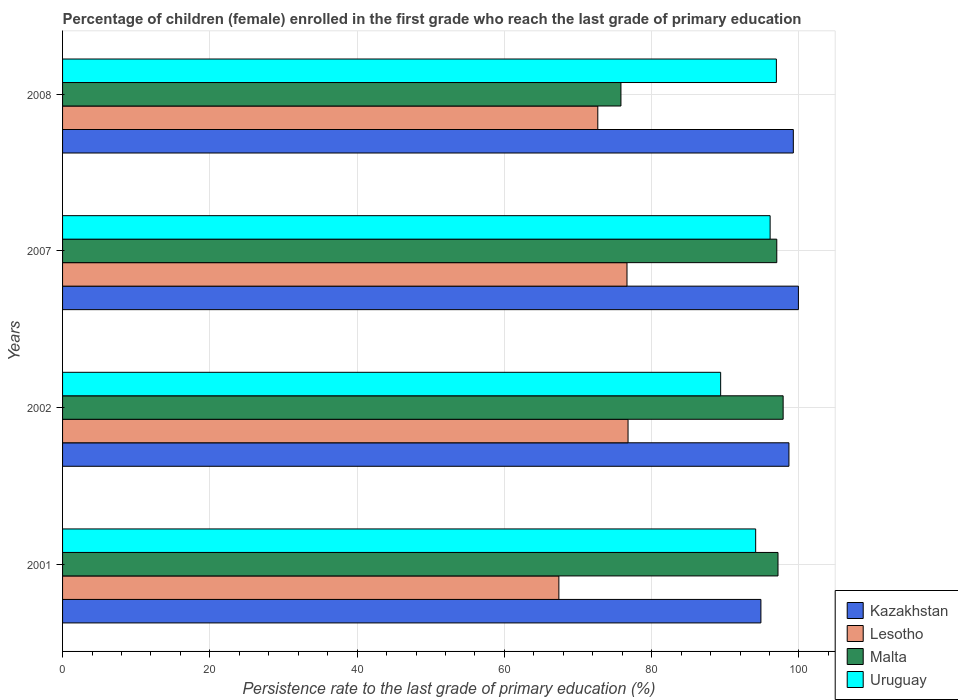How many groups of bars are there?
Provide a short and direct response. 4. Are the number of bars per tick equal to the number of legend labels?
Your answer should be compact. Yes. Are the number of bars on each tick of the Y-axis equal?
Your answer should be very brief. Yes. How many bars are there on the 4th tick from the top?
Ensure brevity in your answer.  4. What is the persistence rate of children in Kazakhstan in 2002?
Your answer should be compact. 98.65. Across all years, what is the maximum persistence rate of children in Malta?
Offer a very short reply. 97.86. Across all years, what is the minimum persistence rate of children in Uruguay?
Your response must be concise. 89.37. In which year was the persistence rate of children in Malta maximum?
Ensure brevity in your answer.  2002. In which year was the persistence rate of children in Kazakhstan minimum?
Keep it short and to the point. 2001. What is the total persistence rate of children in Lesotho in the graph?
Make the answer very short. 293.54. What is the difference between the persistence rate of children in Malta in 2001 and that in 2007?
Provide a short and direct response. 0.16. What is the difference between the persistence rate of children in Uruguay in 2007 and the persistence rate of children in Kazakhstan in 2001?
Make the answer very short. 1.25. What is the average persistence rate of children in Uruguay per year?
Your response must be concise. 94.13. In the year 2001, what is the difference between the persistence rate of children in Kazakhstan and persistence rate of children in Uruguay?
Your response must be concise. 0.71. What is the ratio of the persistence rate of children in Uruguay in 2002 to that in 2008?
Provide a short and direct response. 0.92. Is the difference between the persistence rate of children in Kazakhstan in 2001 and 2008 greater than the difference between the persistence rate of children in Uruguay in 2001 and 2008?
Ensure brevity in your answer.  No. What is the difference between the highest and the second highest persistence rate of children in Kazakhstan?
Keep it short and to the point. 0.69. What is the difference between the highest and the lowest persistence rate of children in Malta?
Make the answer very short. 22.03. In how many years, is the persistence rate of children in Kazakhstan greater than the average persistence rate of children in Kazakhstan taken over all years?
Your response must be concise. 3. Is the sum of the persistence rate of children in Malta in 2001 and 2008 greater than the maximum persistence rate of children in Kazakhstan across all years?
Offer a terse response. Yes. What does the 3rd bar from the top in 2007 represents?
Your answer should be very brief. Lesotho. What does the 4th bar from the bottom in 2002 represents?
Ensure brevity in your answer.  Uruguay. Is it the case that in every year, the sum of the persistence rate of children in Malta and persistence rate of children in Lesotho is greater than the persistence rate of children in Kazakhstan?
Offer a very short reply. Yes. Are all the bars in the graph horizontal?
Your answer should be compact. Yes. What is the difference between two consecutive major ticks on the X-axis?
Keep it short and to the point. 20. Are the values on the major ticks of X-axis written in scientific E-notation?
Give a very brief answer. No. Does the graph contain any zero values?
Ensure brevity in your answer.  No. How are the legend labels stacked?
Your answer should be compact. Vertical. What is the title of the graph?
Provide a short and direct response. Percentage of children (female) enrolled in the first grade who reach the last grade of primary education. Does "Tanzania" appear as one of the legend labels in the graph?
Provide a short and direct response. No. What is the label or title of the X-axis?
Your answer should be very brief. Persistence rate to the last grade of primary education (%). What is the label or title of the Y-axis?
Keep it short and to the point. Years. What is the Persistence rate to the last grade of primary education (%) of Kazakhstan in 2001?
Offer a terse response. 94.84. What is the Persistence rate to the last grade of primary education (%) of Lesotho in 2001?
Your answer should be very brief. 67.4. What is the Persistence rate to the last grade of primary education (%) of Malta in 2001?
Give a very brief answer. 97.16. What is the Persistence rate to the last grade of primary education (%) in Uruguay in 2001?
Make the answer very short. 94.13. What is the Persistence rate to the last grade of primary education (%) in Kazakhstan in 2002?
Provide a succinct answer. 98.65. What is the Persistence rate to the last grade of primary education (%) of Lesotho in 2002?
Your response must be concise. 76.79. What is the Persistence rate to the last grade of primary education (%) in Malta in 2002?
Your answer should be compact. 97.86. What is the Persistence rate to the last grade of primary education (%) of Uruguay in 2002?
Ensure brevity in your answer.  89.37. What is the Persistence rate to the last grade of primary education (%) of Kazakhstan in 2007?
Offer a very short reply. 99.93. What is the Persistence rate to the last grade of primary education (%) of Lesotho in 2007?
Make the answer very short. 76.65. What is the Persistence rate to the last grade of primary education (%) of Malta in 2007?
Make the answer very short. 97. What is the Persistence rate to the last grade of primary education (%) of Uruguay in 2007?
Keep it short and to the point. 96.09. What is the Persistence rate to the last grade of primary education (%) of Kazakhstan in 2008?
Offer a terse response. 99.24. What is the Persistence rate to the last grade of primary education (%) of Lesotho in 2008?
Offer a very short reply. 72.69. What is the Persistence rate to the last grade of primary education (%) of Malta in 2008?
Your answer should be compact. 75.83. What is the Persistence rate to the last grade of primary education (%) of Uruguay in 2008?
Give a very brief answer. 96.94. Across all years, what is the maximum Persistence rate to the last grade of primary education (%) in Kazakhstan?
Make the answer very short. 99.93. Across all years, what is the maximum Persistence rate to the last grade of primary education (%) of Lesotho?
Offer a terse response. 76.79. Across all years, what is the maximum Persistence rate to the last grade of primary education (%) of Malta?
Offer a terse response. 97.86. Across all years, what is the maximum Persistence rate to the last grade of primary education (%) of Uruguay?
Offer a very short reply. 96.94. Across all years, what is the minimum Persistence rate to the last grade of primary education (%) of Kazakhstan?
Give a very brief answer. 94.84. Across all years, what is the minimum Persistence rate to the last grade of primary education (%) of Lesotho?
Ensure brevity in your answer.  67.4. Across all years, what is the minimum Persistence rate to the last grade of primary education (%) in Malta?
Offer a terse response. 75.83. Across all years, what is the minimum Persistence rate to the last grade of primary education (%) of Uruguay?
Offer a very short reply. 89.37. What is the total Persistence rate to the last grade of primary education (%) in Kazakhstan in the graph?
Offer a very short reply. 392.66. What is the total Persistence rate to the last grade of primary education (%) of Lesotho in the graph?
Provide a succinct answer. 293.54. What is the total Persistence rate to the last grade of primary education (%) of Malta in the graph?
Provide a succinct answer. 367.85. What is the total Persistence rate to the last grade of primary education (%) in Uruguay in the graph?
Ensure brevity in your answer.  376.53. What is the difference between the Persistence rate to the last grade of primary education (%) of Kazakhstan in 2001 and that in 2002?
Your response must be concise. -3.81. What is the difference between the Persistence rate to the last grade of primary education (%) of Lesotho in 2001 and that in 2002?
Give a very brief answer. -9.39. What is the difference between the Persistence rate to the last grade of primary education (%) of Malta in 2001 and that in 2002?
Keep it short and to the point. -0.7. What is the difference between the Persistence rate to the last grade of primary education (%) of Uruguay in 2001 and that in 2002?
Your answer should be compact. 4.76. What is the difference between the Persistence rate to the last grade of primary education (%) in Kazakhstan in 2001 and that in 2007?
Your response must be concise. -5.09. What is the difference between the Persistence rate to the last grade of primary education (%) of Lesotho in 2001 and that in 2007?
Your answer should be compact. -9.25. What is the difference between the Persistence rate to the last grade of primary education (%) of Malta in 2001 and that in 2007?
Ensure brevity in your answer.  0.16. What is the difference between the Persistence rate to the last grade of primary education (%) of Uruguay in 2001 and that in 2007?
Offer a very short reply. -1.96. What is the difference between the Persistence rate to the last grade of primary education (%) of Kazakhstan in 2001 and that in 2008?
Your answer should be very brief. -4.4. What is the difference between the Persistence rate to the last grade of primary education (%) in Lesotho in 2001 and that in 2008?
Provide a succinct answer. -5.29. What is the difference between the Persistence rate to the last grade of primary education (%) of Malta in 2001 and that in 2008?
Give a very brief answer. 21.33. What is the difference between the Persistence rate to the last grade of primary education (%) in Uruguay in 2001 and that in 2008?
Ensure brevity in your answer.  -2.81. What is the difference between the Persistence rate to the last grade of primary education (%) of Kazakhstan in 2002 and that in 2007?
Your answer should be very brief. -1.29. What is the difference between the Persistence rate to the last grade of primary education (%) of Lesotho in 2002 and that in 2007?
Give a very brief answer. 0.14. What is the difference between the Persistence rate to the last grade of primary education (%) in Malta in 2002 and that in 2007?
Your response must be concise. 0.86. What is the difference between the Persistence rate to the last grade of primary education (%) in Uruguay in 2002 and that in 2007?
Give a very brief answer. -6.72. What is the difference between the Persistence rate to the last grade of primary education (%) in Kazakhstan in 2002 and that in 2008?
Offer a very short reply. -0.6. What is the difference between the Persistence rate to the last grade of primary education (%) in Lesotho in 2002 and that in 2008?
Provide a succinct answer. 4.11. What is the difference between the Persistence rate to the last grade of primary education (%) of Malta in 2002 and that in 2008?
Your answer should be compact. 22.03. What is the difference between the Persistence rate to the last grade of primary education (%) in Uruguay in 2002 and that in 2008?
Give a very brief answer. -7.57. What is the difference between the Persistence rate to the last grade of primary education (%) of Kazakhstan in 2007 and that in 2008?
Your answer should be very brief. 0.69. What is the difference between the Persistence rate to the last grade of primary education (%) of Lesotho in 2007 and that in 2008?
Make the answer very short. 3.97. What is the difference between the Persistence rate to the last grade of primary education (%) of Malta in 2007 and that in 2008?
Ensure brevity in your answer.  21.16. What is the difference between the Persistence rate to the last grade of primary education (%) in Uruguay in 2007 and that in 2008?
Provide a short and direct response. -0.85. What is the difference between the Persistence rate to the last grade of primary education (%) of Kazakhstan in 2001 and the Persistence rate to the last grade of primary education (%) of Lesotho in 2002?
Provide a short and direct response. 18.04. What is the difference between the Persistence rate to the last grade of primary education (%) of Kazakhstan in 2001 and the Persistence rate to the last grade of primary education (%) of Malta in 2002?
Ensure brevity in your answer.  -3.02. What is the difference between the Persistence rate to the last grade of primary education (%) in Kazakhstan in 2001 and the Persistence rate to the last grade of primary education (%) in Uruguay in 2002?
Keep it short and to the point. 5.47. What is the difference between the Persistence rate to the last grade of primary education (%) in Lesotho in 2001 and the Persistence rate to the last grade of primary education (%) in Malta in 2002?
Your answer should be compact. -30.46. What is the difference between the Persistence rate to the last grade of primary education (%) of Lesotho in 2001 and the Persistence rate to the last grade of primary education (%) of Uruguay in 2002?
Your answer should be very brief. -21.97. What is the difference between the Persistence rate to the last grade of primary education (%) in Malta in 2001 and the Persistence rate to the last grade of primary education (%) in Uruguay in 2002?
Keep it short and to the point. 7.79. What is the difference between the Persistence rate to the last grade of primary education (%) of Kazakhstan in 2001 and the Persistence rate to the last grade of primary education (%) of Lesotho in 2007?
Your answer should be very brief. 18.19. What is the difference between the Persistence rate to the last grade of primary education (%) in Kazakhstan in 2001 and the Persistence rate to the last grade of primary education (%) in Malta in 2007?
Your answer should be compact. -2.16. What is the difference between the Persistence rate to the last grade of primary education (%) in Kazakhstan in 2001 and the Persistence rate to the last grade of primary education (%) in Uruguay in 2007?
Your answer should be compact. -1.25. What is the difference between the Persistence rate to the last grade of primary education (%) of Lesotho in 2001 and the Persistence rate to the last grade of primary education (%) of Malta in 2007?
Your answer should be very brief. -29.59. What is the difference between the Persistence rate to the last grade of primary education (%) of Lesotho in 2001 and the Persistence rate to the last grade of primary education (%) of Uruguay in 2007?
Provide a short and direct response. -28.69. What is the difference between the Persistence rate to the last grade of primary education (%) in Malta in 2001 and the Persistence rate to the last grade of primary education (%) in Uruguay in 2007?
Your answer should be very brief. 1.07. What is the difference between the Persistence rate to the last grade of primary education (%) of Kazakhstan in 2001 and the Persistence rate to the last grade of primary education (%) of Lesotho in 2008?
Make the answer very short. 22.15. What is the difference between the Persistence rate to the last grade of primary education (%) of Kazakhstan in 2001 and the Persistence rate to the last grade of primary education (%) of Malta in 2008?
Give a very brief answer. 19.01. What is the difference between the Persistence rate to the last grade of primary education (%) of Kazakhstan in 2001 and the Persistence rate to the last grade of primary education (%) of Uruguay in 2008?
Provide a succinct answer. -2.1. What is the difference between the Persistence rate to the last grade of primary education (%) of Lesotho in 2001 and the Persistence rate to the last grade of primary education (%) of Malta in 2008?
Offer a very short reply. -8.43. What is the difference between the Persistence rate to the last grade of primary education (%) in Lesotho in 2001 and the Persistence rate to the last grade of primary education (%) in Uruguay in 2008?
Make the answer very short. -29.54. What is the difference between the Persistence rate to the last grade of primary education (%) in Malta in 2001 and the Persistence rate to the last grade of primary education (%) in Uruguay in 2008?
Your response must be concise. 0.22. What is the difference between the Persistence rate to the last grade of primary education (%) of Kazakhstan in 2002 and the Persistence rate to the last grade of primary education (%) of Lesotho in 2007?
Ensure brevity in your answer.  21.99. What is the difference between the Persistence rate to the last grade of primary education (%) of Kazakhstan in 2002 and the Persistence rate to the last grade of primary education (%) of Malta in 2007?
Ensure brevity in your answer.  1.65. What is the difference between the Persistence rate to the last grade of primary education (%) of Kazakhstan in 2002 and the Persistence rate to the last grade of primary education (%) of Uruguay in 2007?
Give a very brief answer. 2.56. What is the difference between the Persistence rate to the last grade of primary education (%) in Lesotho in 2002 and the Persistence rate to the last grade of primary education (%) in Malta in 2007?
Your response must be concise. -20.2. What is the difference between the Persistence rate to the last grade of primary education (%) of Lesotho in 2002 and the Persistence rate to the last grade of primary education (%) of Uruguay in 2007?
Provide a succinct answer. -19.3. What is the difference between the Persistence rate to the last grade of primary education (%) in Malta in 2002 and the Persistence rate to the last grade of primary education (%) in Uruguay in 2007?
Keep it short and to the point. 1.77. What is the difference between the Persistence rate to the last grade of primary education (%) of Kazakhstan in 2002 and the Persistence rate to the last grade of primary education (%) of Lesotho in 2008?
Make the answer very short. 25.96. What is the difference between the Persistence rate to the last grade of primary education (%) of Kazakhstan in 2002 and the Persistence rate to the last grade of primary education (%) of Malta in 2008?
Provide a short and direct response. 22.81. What is the difference between the Persistence rate to the last grade of primary education (%) of Kazakhstan in 2002 and the Persistence rate to the last grade of primary education (%) of Uruguay in 2008?
Ensure brevity in your answer.  1.71. What is the difference between the Persistence rate to the last grade of primary education (%) of Lesotho in 2002 and the Persistence rate to the last grade of primary education (%) of Malta in 2008?
Give a very brief answer. 0.96. What is the difference between the Persistence rate to the last grade of primary education (%) of Lesotho in 2002 and the Persistence rate to the last grade of primary education (%) of Uruguay in 2008?
Give a very brief answer. -20.14. What is the difference between the Persistence rate to the last grade of primary education (%) in Malta in 2002 and the Persistence rate to the last grade of primary education (%) in Uruguay in 2008?
Ensure brevity in your answer.  0.92. What is the difference between the Persistence rate to the last grade of primary education (%) of Kazakhstan in 2007 and the Persistence rate to the last grade of primary education (%) of Lesotho in 2008?
Your answer should be compact. 27.24. What is the difference between the Persistence rate to the last grade of primary education (%) in Kazakhstan in 2007 and the Persistence rate to the last grade of primary education (%) in Malta in 2008?
Give a very brief answer. 24.1. What is the difference between the Persistence rate to the last grade of primary education (%) in Kazakhstan in 2007 and the Persistence rate to the last grade of primary education (%) in Uruguay in 2008?
Give a very brief answer. 2.99. What is the difference between the Persistence rate to the last grade of primary education (%) in Lesotho in 2007 and the Persistence rate to the last grade of primary education (%) in Malta in 2008?
Make the answer very short. 0.82. What is the difference between the Persistence rate to the last grade of primary education (%) in Lesotho in 2007 and the Persistence rate to the last grade of primary education (%) in Uruguay in 2008?
Give a very brief answer. -20.29. What is the difference between the Persistence rate to the last grade of primary education (%) in Malta in 2007 and the Persistence rate to the last grade of primary education (%) in Uruguay in 2008?
Offer a very short reply. 0.06. What is the average Persistence rate to the last grade of primary education (%) of Kazakhstan per year?
Your response must be concise. 98.16. What is the average Persistence rate to the last grade of primary education (%) in Lesotho per year?
Offer a very short reply. 73.38. What is the average Persistence rate to the last grade of primary education (%) of Malta per year?
Your answer should be compact. 91.96. What is the average Persistence rate to the last grade of primary education (%) of Uruguay per year?
Your answer should be compact. 94.13. In the year 2001, what is the difference between the Persistence rate to the last grade of primary education (%) in Kazakhstan and Persistence rate to the last grade of primary education (%) in Lesotho?
Your answer should be compact. 27.44. In the year 2001, what is the difference between the Persistence rate to the last grade of primary education (%) in Kazakhstan and Persistence rate to the last grade of primary education (%) in Malta?
Provide a short and direct response. -2.32. In the year 2001, what is the difference between the Persistence rate to the last grade of primary education (%) of Kazakhstan and Persistence rate to the last grade of primary education (%) of Uruguay?
Ensure brevity in your answer.  0.71. In the year 2001, what is the difference between the Persistence rate to the last grade of primary education (%) of Lesotho and Persistence rate to the last grade of primary education (%) of Malta?
Offer a very short reply. -29.76. In the year 2001, what is the difference between the Persistence rate to the last grade of primary education (%) of Lesotho and Persistence rate to the last grade of primary education (%) of Uruguay?
Your answer should be compact. -26.73. In the year 2001, what is the difference between the Persistence rate to the last grade of primary education (%) in Malta and Persistence rate to the last grade of primary education (%) in Uruguay?
Keep it short and to the point. 3.03. In the year 2002, what is the difference between the Persistence rate to the last grade of primary education (%) of Kazakhstan and Persistence rate to the last grade of primary education (%) of Lesotho?
Provide a short and direct response. 21.85. In the year 2002, what is the difference between the Persistence rate to the last grade of primary education (%) of Kazakhstan and Persistence rate to the last grade of primary education (%) of Malta?
Provide a succinct answer. 0.79. In the year 2002, what is the difference between the Persistence rate to the last grade of primary education (%) in Kazakhstan and Persistence rate to the last grade of primary education (%) in Uruguay?
Your answer should be compact. 9.27. In the year 2002, what is the difference between the Persistence rate to the last grade of primary education (%) of Lesotho and Persistence rate to the last grade of primary education (%) of Malta?
Your response must be concise. -21.06. In the year 2002, what is the difference between the Persistence rate to the last grade of primary education (%) in Lesotho and Persistence rate to the last grade of primary education (%) in Uruguay?
Offer a terse response. -12.58. In the year 2002, what is the difference between the Persistence rate to the last grade of primary education (%) of Malta and Persistence rate to the last grade of primary education (%) of Uruguay?
Ensure brevity in your answer.  8.49. In the year 2007, what is the difference between the Persistence rate to the last grade of primary education (%) of Kazakhstan and Persistence rate to the last grade of primary education (%) of Lesotho?
Your answer should be very brief. 23.28. In the year 2007, what is the difference between the Persistence rate to the last grade of primary education (%) in Kazakhstan and Persistence rate to the last grade of primary education (%) in Malta?
Provide a short and direct response. 2.94. In the year 2007, what is the difference between the Persistence rate to the last grade of primary education (%) of Kazakhstan and Persistence rate to the last grade of primary education (%) of Uruguay?
Your answer should be very brief. 3.84. In the year 2007, what is the difference between the Persistence rate to the last grade of primary education (%) in Lesotho and Persistence rate to the last grade of primary education (%) in Malta?
Keep it short and to the point. -20.34. In the year 2007, what is the difference between the Persistence rate to the last grade of primary education (%) of Lesotho and Persistence rate to the last grade of primary education (%) of Uruguay?
Keep it short and to the point. -19.44. In the year 2007, what is the difference between the Persistence rate to the last grade of primary education (%) in Malta and Persistence rate to the last grade of primary education (%) in Uruguay?
Provide a short and direct response. 0.91. In the year 2008, what is the difference between the Persistence rate to the last grade of primary education (%) in Kazakhstan and Persistence rate to the last grade of primary education (%) in Lesotho?
Keep it short and to the point. 26.55. In the year 2008, what is the difference between the Persistence rate to the last grade of primary education (%) in Kazakhstan and Persistence rate to the last grade of primary education (%) in Malta?
Offer a terse response. 23.41. In the year 2008, what is the difference between the Persistence rate to the last grade of primary education (%) in Kazakhstan and Persistence rate to the last grade of primary education (%) in Uruguay?
Keep it short and to the point. 2.3. In the year 2008, what is the difference between the Persistence rate to the last grade of primary education (%) in Lesotho and Persistence rate to the last grade of primary education (%) in Malta?
Make the answer very short. -3.14. In the year 2008, what is the difference between the Persistence rate to the last grade of primary education (%) of Lesotho and Persistence rate to the last grade of primary education (%) of Uruguay?
Give a very brief answer. -24.25. In the year 2008, what is the difference between the Persistence rate to the last grade of primary education (%) in Malta and Persistence rate to the last grade of primary education (%) in Uruguay?
Your answer should be compact. -21.11. What is the ratio of the Persistence rate to the last grade of primary education (%) of Kazakhstan in 2001 to that in 2002?
Your answer should be very brief. 0.96. What is the ratio of the Persistence rate to the last grade of primary education (%) in Lesotho in 2001 to that in 2002?
Offer a very short reply. 0.88. What is the ratio of the Persistence rate to the last grade of primary education (%) of Uruguay in 2001 to that in 2002?
Keep it short and to the point. 1.05. What is the ratio of the Persistence rate to the last grade of primary education (%) in Kazakhstan in 2001 to that in 2007?
Offer a terse response. 0.95. What is the ratio of the Persistence rate to the last grade of primary education (%) of Lesotho in 2001 to that in 2007?
Give a very brief answer. 0.88. What is the ratio of the Persistence rate to the last grade of primary education (%) of Malta in 2001 to that in 2007?
Your answer should be compact. 1. What is the ratio of the Persistence rate to the last grade of primary education (%) of Uruguay in 2001 to that in 2007?
Give a very brief answer. 0.98. What is the ratio of the Persistence rate to the last grade of primary education (%) of Kazakhstan in 2001 to that in 2008?
Offer a very short reply. 0.96. What is the ratio of the Persistence rate to the last grade of primary education (%) of Lesotho in 2001 to that in 2008?
Provide a succinct answer. 0.93. What is the ratio of the Persistence rate to the last grade of primary education (%) of Malta in 2001 to that in 2008?
Ensure brevity in your answer.  1.28. What is the ratio of the Persistence rate to the last grade of primary education (%) of Kazakhstan in 2002 to that in 2007?
Your answer should be very brief. 0.99. What is the ratio of the Persistence rate to the last grade of primary education (%) in Lesotho in 2002 to that in 2007?
Keep it short and to the point. 1. What is the ratio of the Persistence rate to the last grade of primary education (%) of Malta in 2002 to that in 2007?
Offer a terse response. 1.01. What is the ratio of the Persistence rate to the last grade of primary education (%) of Uruguay in 2002 to that in 2007?
Give a very brief answer. 0.93. What is the ratio of the Persistence rate to the last grade of primary education (%) of Kazakhstan in 2002 to that in 2008?
Ensure brevity in your answer.  0.99. What is the ratio of the Persistence rate to the last grade of primary education (%) in Lesotho in 2002 to that in 2008?
Ensure brevity in your answer.  1.06. What is the ratio of the Persistence rate to the last grade of primary education (%) of Malta in 2002 to that in 2008?
Ensure brevity in your answer.  1.29. What is the ratio of the Persistence rate to the last grade of primary education (%) of Uruguay in 2002 to that in 2008?
Keep it short and to the point. 0.92. What is the ratio of the Persistence rate to the last grade of primary education (%) in Lesotho in 2007 to that in 2008?
Offer a very short reply. 1.05. What is the ratio of the Persistence rate to the last grade of primary education (%) in Malta in 2007 to that in 2008?
Offer a very short reply. 1.28. What is the difference between the highest and the second highest Persistence rate to the last grade of primary education (%) in Kazakhstan?
Keep it short and to the point. 0.69. What is the difference between the highest and the second highest Persistence rate to the last grade of primary education (%) of Lesotho?
Provide a short and direct response. 0.14. What is the difference between the highest and the second highest Persistence rate to the last grade of primary education (%) of Malta?
Make the answer very short. 0.7. What is the difference between the highest and the second highest Persistence rate to the last grade of primary education (%) in Uruguay?
Your answer should be compact. 0.85. What is the difference between the highest and the lowest Persistence rate to the last grade of primary education (%) in Kazakhstan?
Ensure brevity in your answer.  5.09. What is the difference between the highest and the lowest Persistence rate to the last grade of primary education (%) in Lesotho?
Provide a short and direct response. 9.39. What is the difference between the highest and the lowest Persistence rate to the last grade of primary education (%) of Malta?
Make the answer very short. 22.03. What is the difference between the highest and the lowest Persistence rate to the last grade of primary education (%) of Uruguay?
Offer a very short reply. 7.57. 